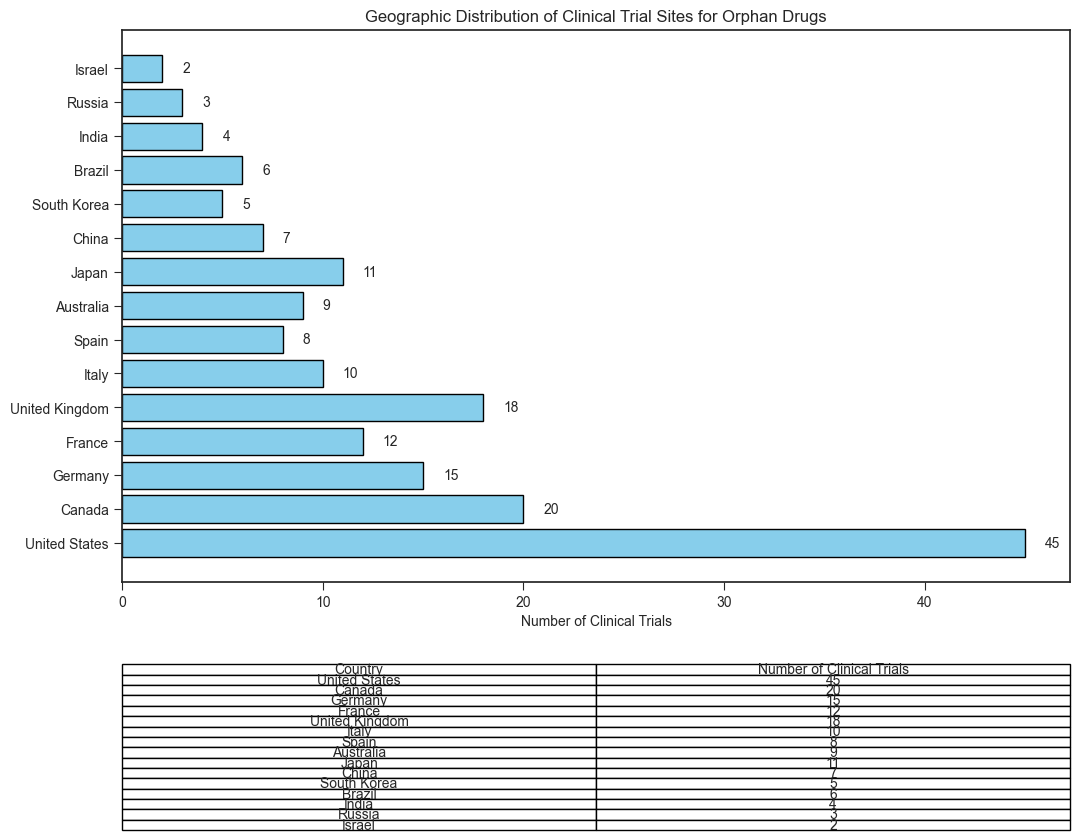What is the total number of clinical trials across all countries? To find the total number of clinical trials, sum the number of clinical trials for all countries: 45 (United States) + 20 (Canada) + 15 (Germany) + 12 (France) + 18 (United Kingdom) + 10 (Italy) + 8 (Spain) + 9 (Australia) + 11 (Japan) + 7 (China) + 5 (South Korea) + 6 (Brazil) + 4 (India) + 3 (Russia) + 2 (Israel) = 175.
Answer: 175 Which country has the most clinical trial sites? The country with the most clinical trial sites is the one with the longest bar in the plot and the highest number in the table, which is the United States with 45 clinical trials.
Answer: United States By how much do the clinical trials in the United States exceed those in the United Kingdom? Subtract the number of clinical trials in the United Kingdom (18) from those in the United States (45): 45 - 18 = 27.
Answer: 27 What is the average number of clinical trials per country? To find the average, divide the total number of clinical trials by the number of countries: 175 (total trials) ÷ 15 (countries) = 11.67.
Answer: 11.67 How many more clinical trials are conducted in Germany and France combined compared to Japan? Add the number of clinical trials in Germany (15) and France (12) to get 27. Then subtract the number of trials in Japan (11) from this sum: 27 - 11 = 16.
Answer: 16 Which country has the least number of clinical trial sites, and how many does it have? The country with the least number of clinical trial sites is the one with the shortest bar in the plot and the lowest number in the table, which is Israel with 2 clinical trials.
Answer: Israel, 2 How do the clinical trials in Canada compare to those in Italy and Japan combined? Add the number of clinical trials in Italy (10) and Japan (11) to get 21. Compare this sum to the number in Canada (20): 20 < 21.
Answer: 21 (Italy and Japan combined), 20 (Canada) What is the range of the number of clinical trials across the countries? To find the range, subtract the smallest number of clinical trials (Israel, 2) from the largest number (United States, 45): 45 - 2 = 43.
Answer: 43 